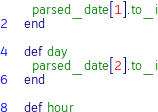<code> <loc_0><loc_0><loc_500><loc_500><_Ruby_>    parsed_date[1].to_i
  end

  def day
    parsed_date[2].to_i
  end

  def hour</code> 